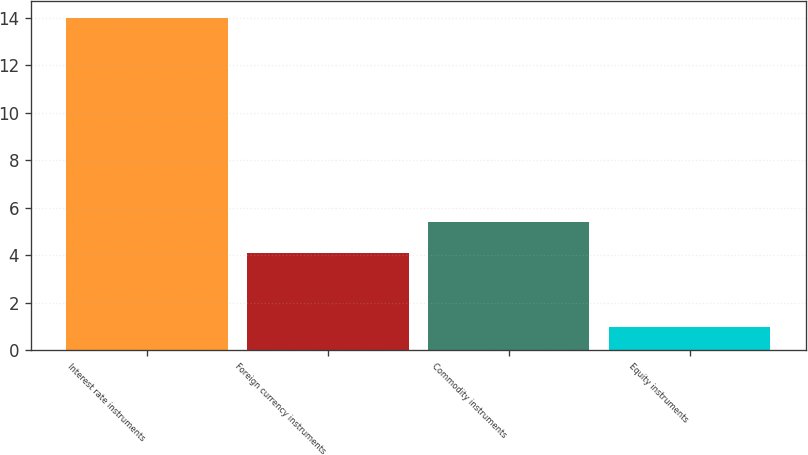Convert chart to OTSL. <chart><loc_0><loc_0><loc_500><loc_500><bar_chart><fcel>Interest rate instruments<fcel>Foreign currency instruments<fcel>Commodity instruments<fcel>Equity instruments<nl><fcel>14<fcel>4.1<fcel>5.4<fcel>1<nl></chart> 